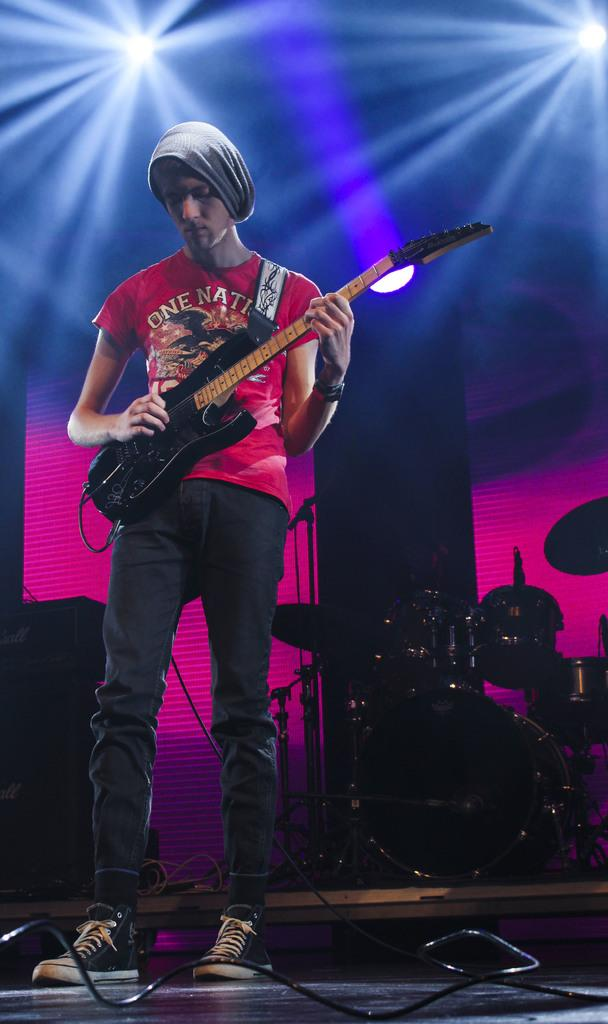Who is the main subject in the image? There is a boy in the image. What is the boy doing in the image? The boy is standing and holding a guitar in his hand. What can be seen in the background of the image? There is a musical band in the background. What else is visible in the image? There are lights visible in the image. What word is the boy trying to spell with his guitar in the image? There is no indication in the image that the boy is trying to spell a word with his guitar. 